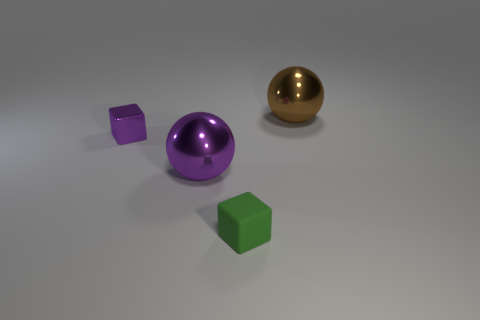Add 2 green blocks. How many objects exist? 6 Add 2 large matte things. How many large matte things exist? 2 Subtract 0 brown cylinders. How many objects are left? 4 Subtract all big metal things. Subtract all large purple objects. How many objects are left? 1 Add 1 purple spheres. How many purple spheres are left? 2 